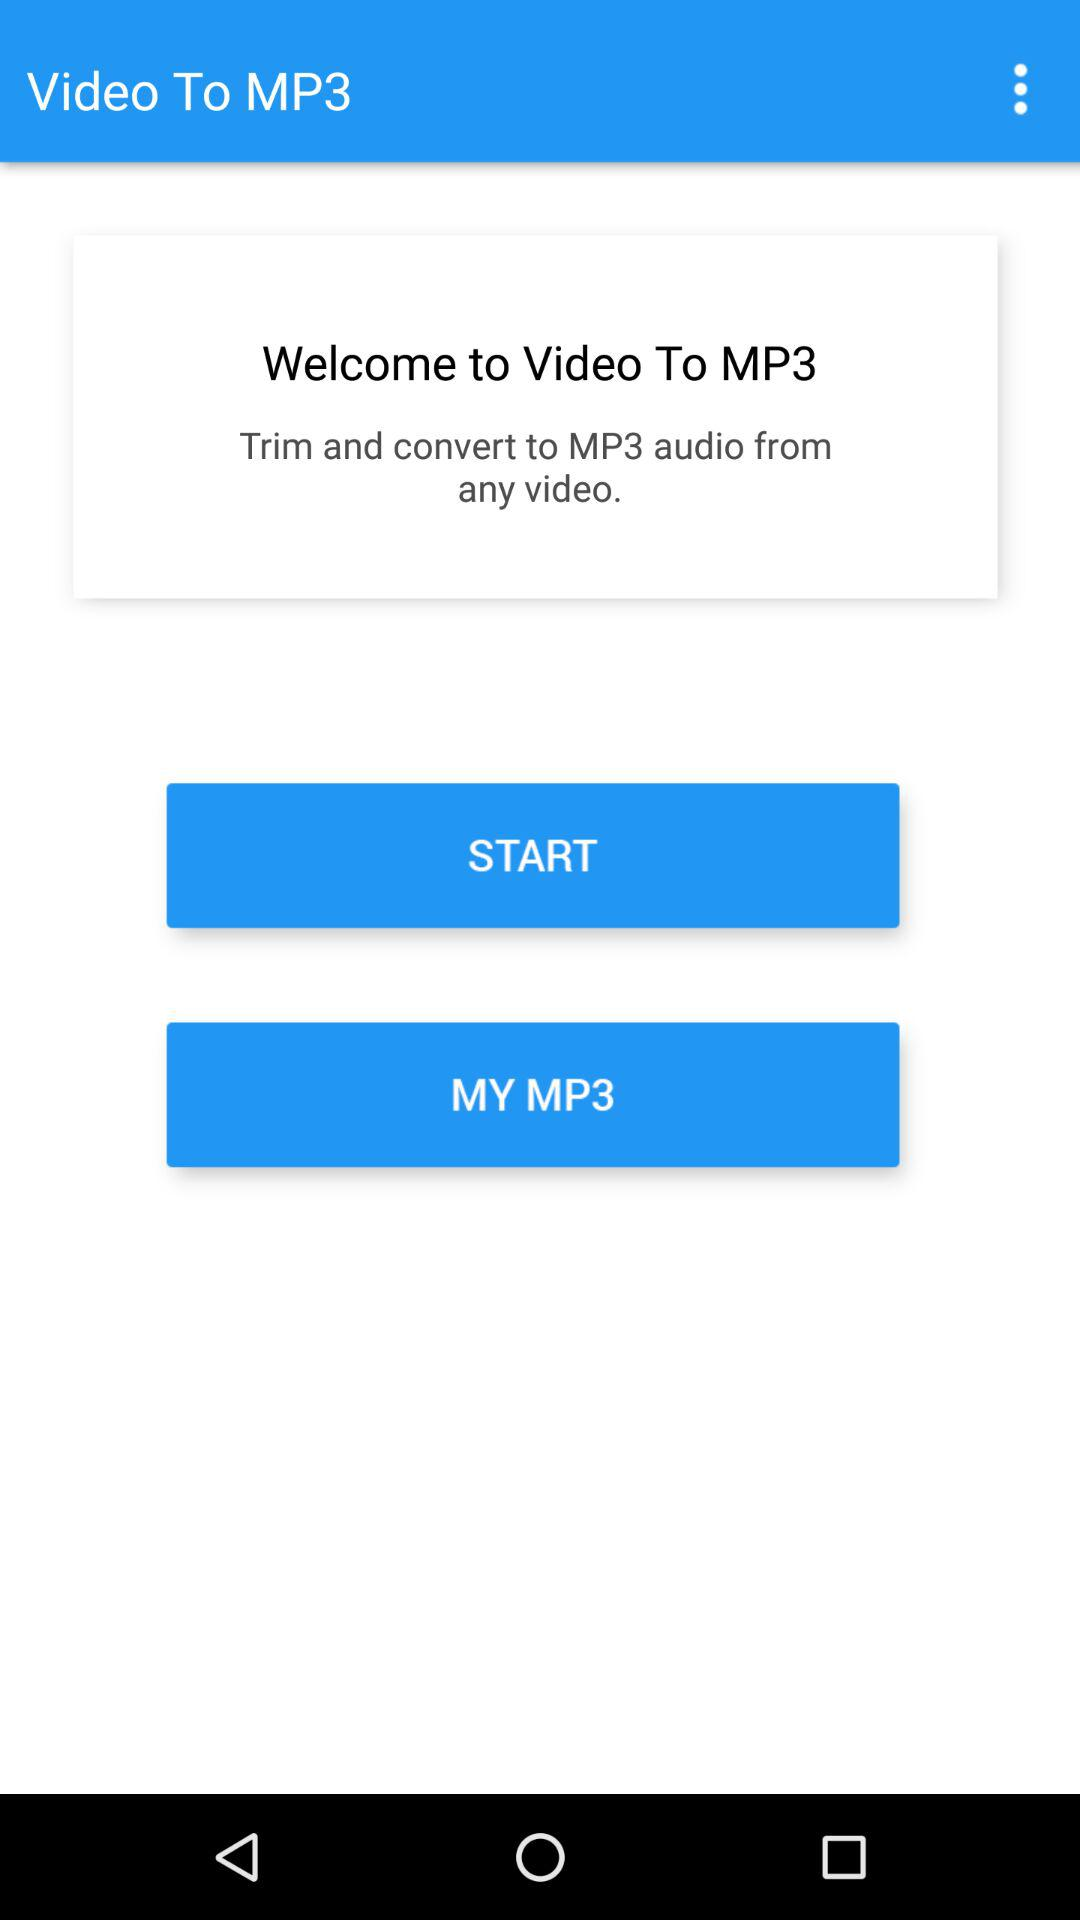In what format can the video be converted? The video can be converted to MP3 audio format. 